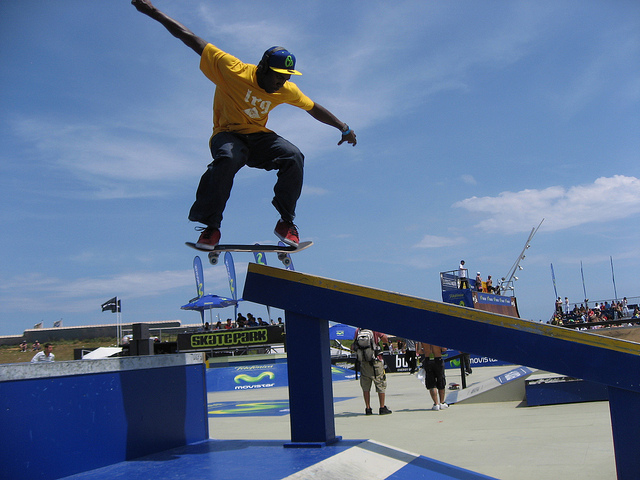Identify and read out the text in this image. SKATEPARK 